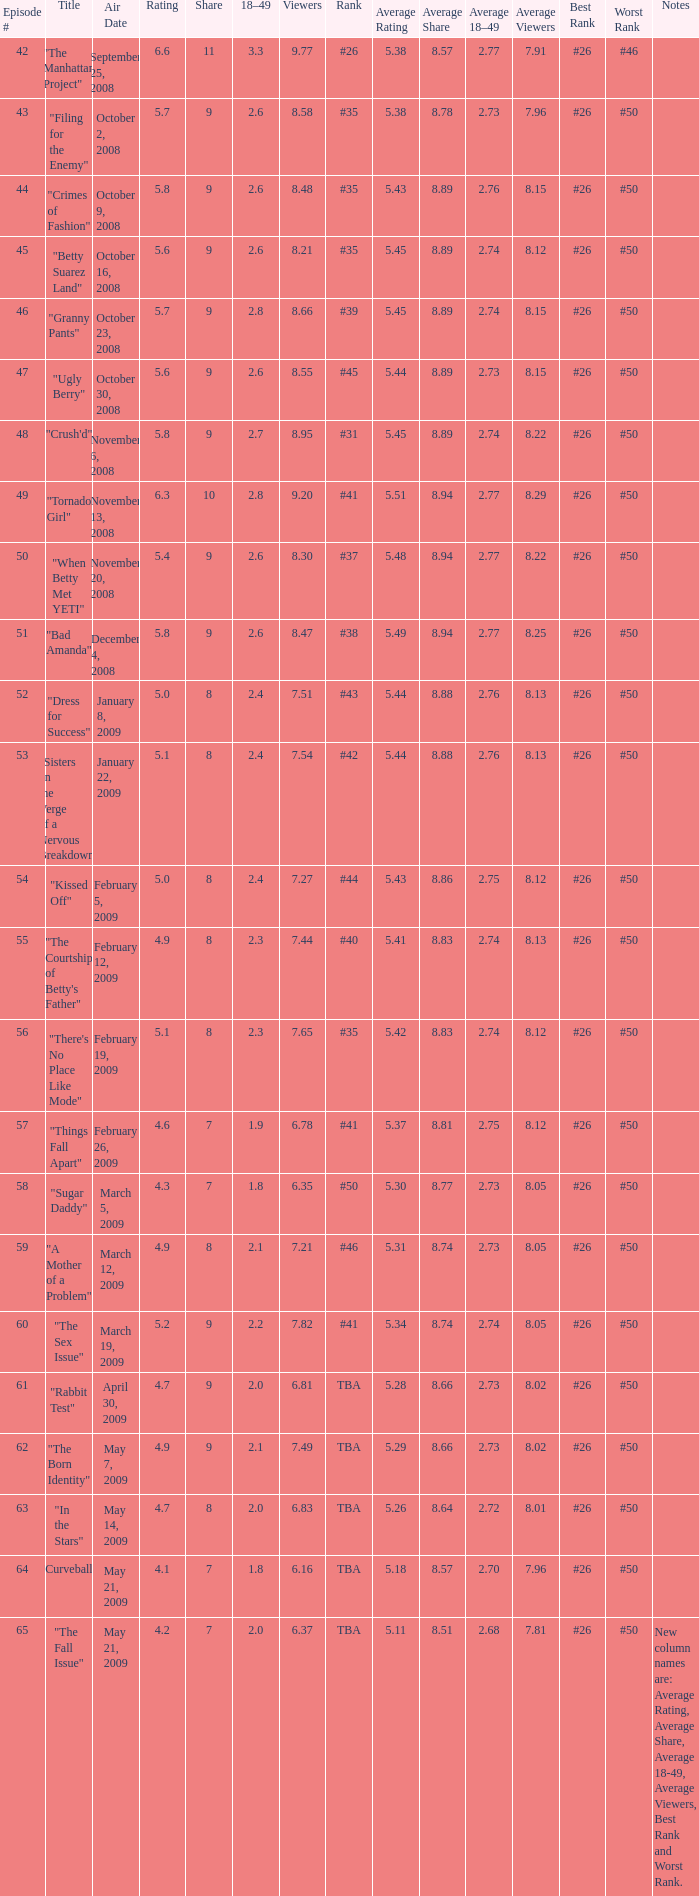What is the Air Date that has a 18–49 larger than 1.9, less than 7.54 viewers and a rating less than 4.9? April 30, 2009, May 14, 2009, May 21, 2009. 